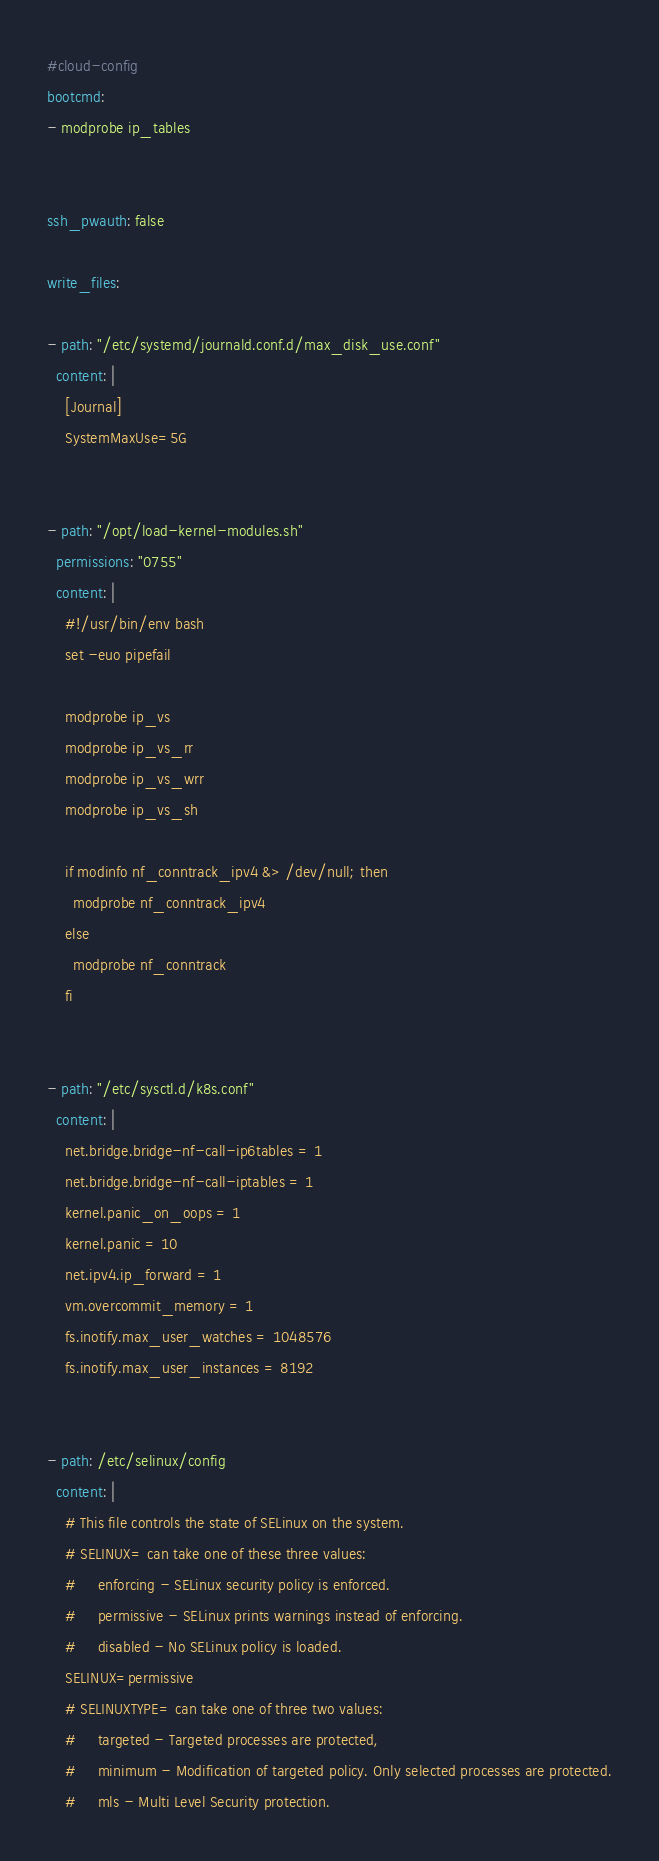<code> <loc_0><loc_0><loc_500><loc_500><_YAML_>#cloud-config
bootcmd:
- modprobe ip_tables


ssh_pwauth: false

write_files:

- path: "/etc/systemd/journald.conf.d/max_disk_use.conf"
  content: |
    [Journal]
    SystemMaxUse=5G


- path: "/opt/load-kernel-modules.sh"
  permissions: "0755"
  content: |
    #!/usr/bin/env bash
    set -euo pipefail

    modprobe ip_vs
    modprobe ip_vs_rr
    modprobe ip_vs_wrr
    modprobe ip_vs_sh

    if modinfo nf_conntrack_ipv4 &> /dev/null; then
      modprobe nf_conntrack_ipv4
    else
      modprobe nf_conntrack
    fi


- path: "/etc/sysctl.d/k8s.conf"
  content: |
    net.bridge.bridge-nf-call-ip6tables = 1
    net.bridge.bridge-nf-call-iptables = 1
    kernel.panic_on_oops = 1
    kernel.panic = 10
    net.ipv4.ip_forward = 1
    vm.overcommit_memory = 1
    fs.inotify.max_user_watches = 1048576
    fs.inotify.max_user_instances = 8192


- path: /etc/selinux/config
  content: |
    # This file controls the state of SELinux on the system.
    # SELINUX= can take one of these three values:
    #     enforcing - SELinux security policy is enforced.
    #     permissive - SELinux prints warnings instead of enforcing.
    #     disabled - No SELinux policy is loaded.
    SELINUX=permissive
    # SELINUXTYPE= can take one of three two values:
    #     targeted - Targeted processes are protected,
    #     minimum - Modification of targeted policy. Only selected processes are protected.
    #     mls - Multi Level Security protection.</code> 